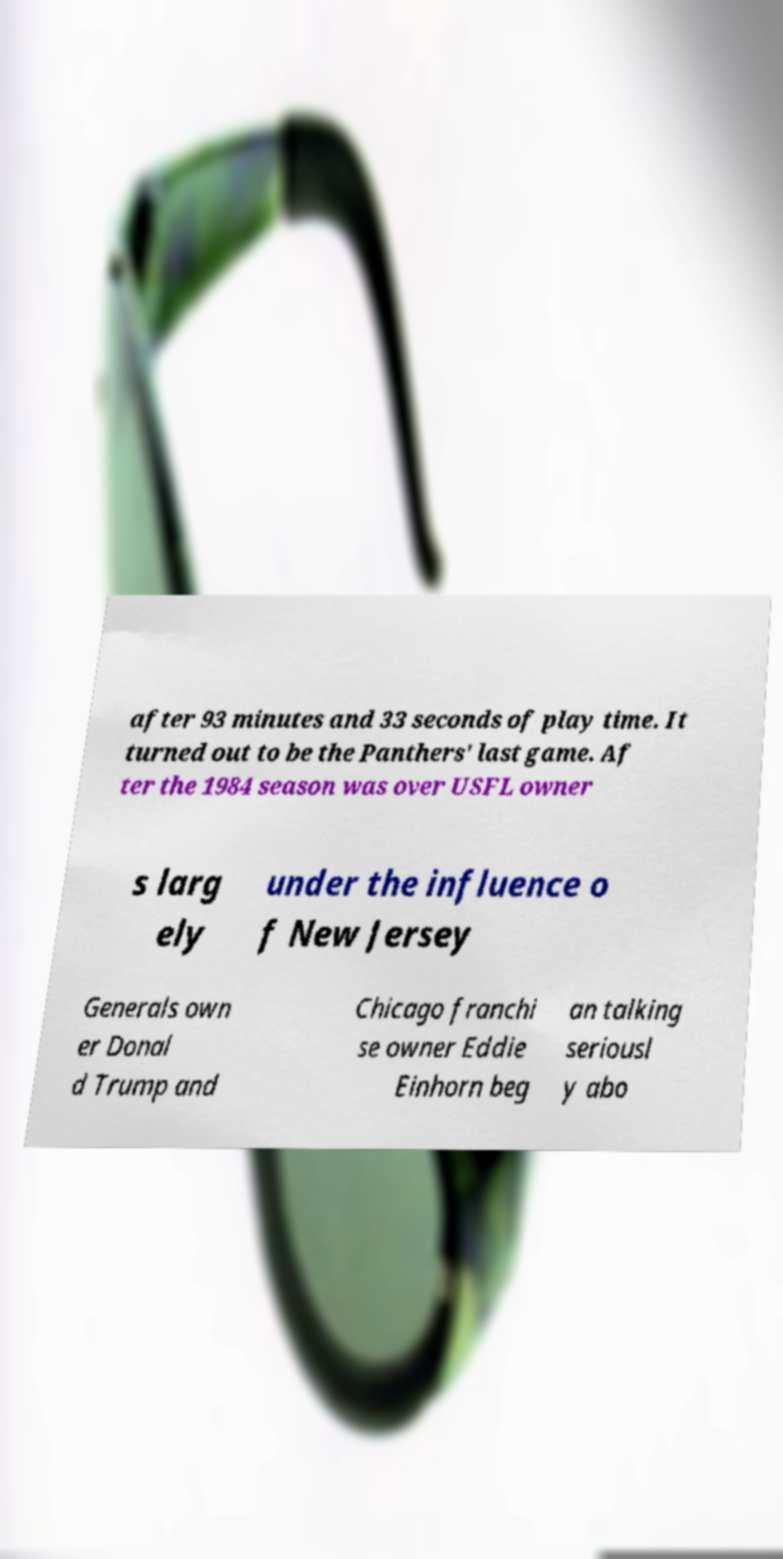There's text embedded in this image that I need extracted. Can you transcribe it verbatim? after 93 minutes and 33 seconds of play time. It turned out to be the Panthers' last game. Af ter the 1984 season was over USFL owner s larg ely under the influence o f New Jersey Generals own er Donal d Trump and Chicago franchi se owner Eddie Einhorn beg an talking seriousl y abo 